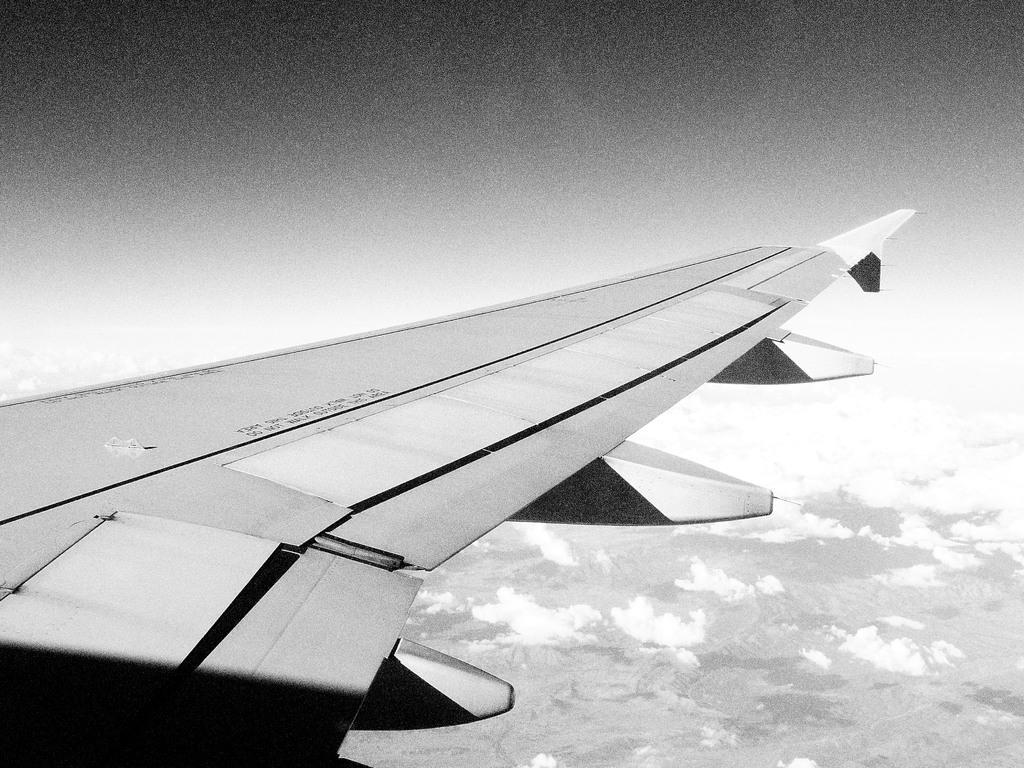Could you give a brief overview of what you see in this image? In this picture I can see there is a air plane wing and in the backdrop there are mountains and some clouds passing by. 